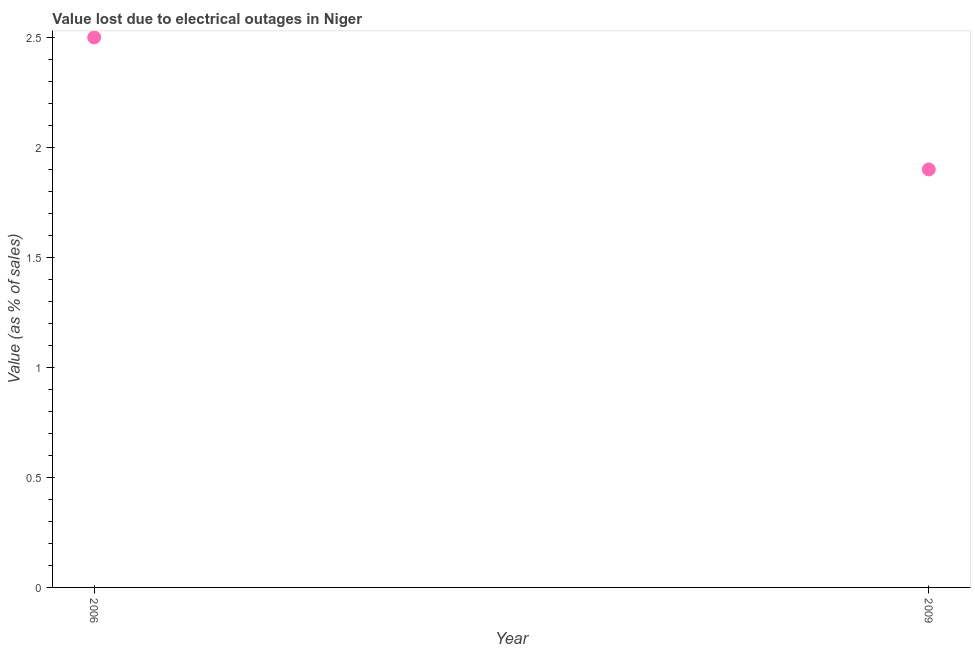What is the value lost due to electrical outages in 2009?
Offer a terse response. 1.9. Across all years, what is the minimum value lost due to electrical outages?
Provide a succinct answer. 1.9. What is the difference between the value lost due to electrical outages in 2006 and 2009?
Keep it short and to the point. 0.6. What is the ratio of the value lost due to electrical outages in 2006 to that in 2009?
Give a very brief answer. 1.32. In how many years, is the value lost due to electrical outages greater than the average value lost due to electrical outages taken over all years?
Your answer should be compact. 1. Does the value lost due to electrical outages monotonically increase over the years?
Give a very brief answer. No. How many dotlines are there?
Provide a succinct answer. 1. What is the difference between two consecutive major ticks on the Y-axis?
Ensure brevity in your answer.  0.5. Are the values on the major ticks of Y-axis written in scientific E-notation?
Your answer should be compact. No. Does the graph contain any zero values?
Make the answer very short. No. Does the graph contain grids?
Give a very brief answer. No. What is the title of the graph?
Your answer should be very brief. Value lost due to electrical outages in Niger. What is the label or title of the Y-axis?
Keep it short and to the point. Value (as % of sales). What is the Value (as % of sales) in 2006?
Give a very brief answer. 2.5. What is the Value (as % of sales) in 2009?
Your answer should be compact. 1.9. What is the ratio of the Value (as % of sales) in 2006 to that in 2009?
Provide a succinct answer. 1.32. 